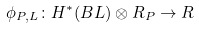Convert formula to latex. <formula><loc_0><loc_0><loc_500><loc_500>\phi _ { P , L } \colon H ^ { * } ( B L ) \otimes R _ { P } \to R</formula> 